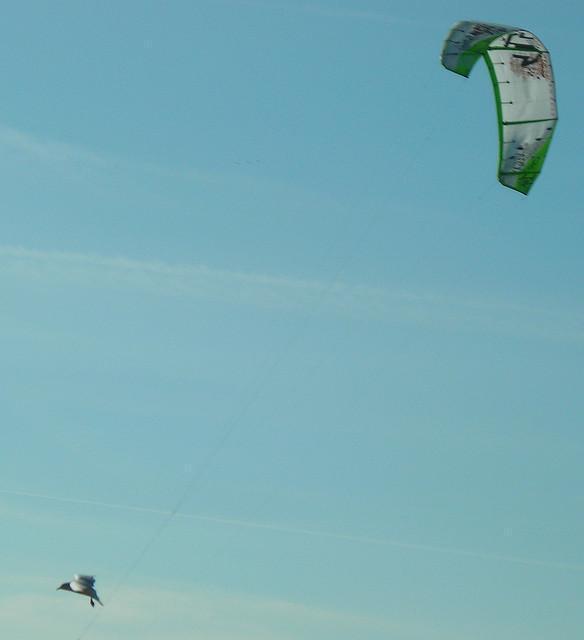How many baby sheep are there?
Give a very brief answer. 0. 